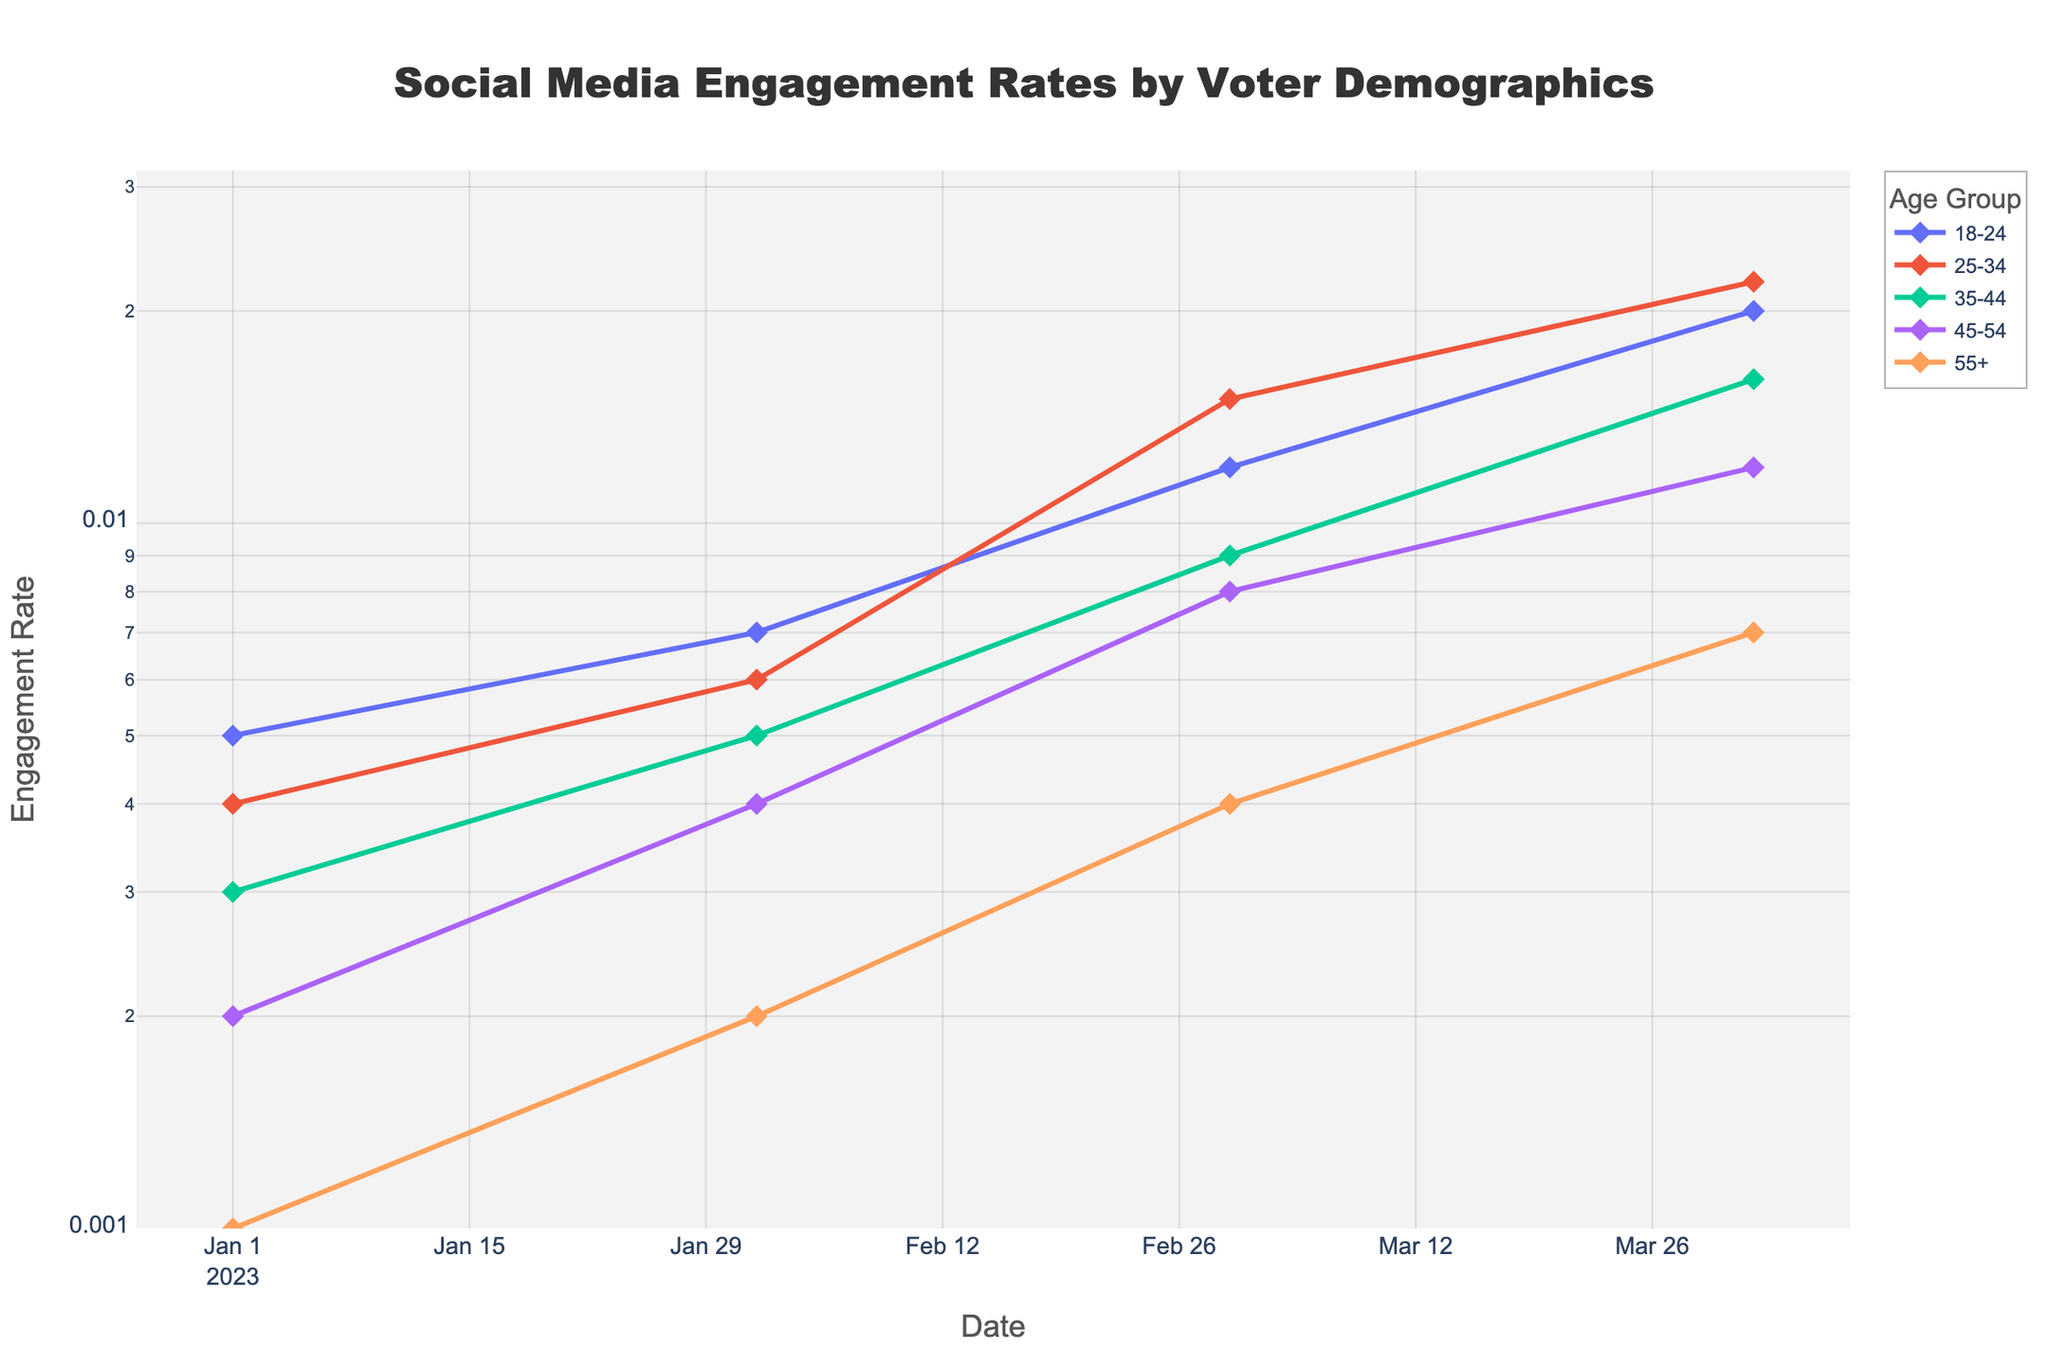What is the title of the plot? The title of the plot is located at the top center and provides a short description of the plot's content.
Answer: Social Media Engagement Rates by Voter Demographics Which voter demographic had the highest engagement rate on 2023-04-01? To find the highest engagement rate on 2023-04-01, examine the end points of the lines for each demographic.
Answer: 25-34 Between which dates did the 18-24 demographic see the fastest growth in engagement rate? To determine this, compare the slopes of the line segments for the 18-24 demographic. The steepest slope indicates the fastest growth.
Answer: 2023-03-01 to 2023-04-01 How many demographic groups are shown in the plot? Count the number of unique lines or legend entries in the plot.
Answer: 5 What is the engagement rate of the 55+ demographic on 2023-02-01? Locate the point on the line for the 55+ demographic at the date 2023-02-01.
Answer: 0.002 How does the engagement rate for the age group 45-54 on 2023-04-01 compare to that on 2023-02-01? Compare the engagement rates for the 45-54 group at the two dates by checking the y-values of those points.
Answer: 3 times higher Which age group showed the smallest change in engagement rates from 2023-01-01 to 2023-04-01? Calculate the difference between the engagement rates on 2023-01-01 and 2023-04-01 for each group, and find the smallest change.
Answer: 55+ What is the trend in engagement rates for the 35-44 age group? Observe the general direction of the 35-44 age group's line over the time period.
Answer: Increasing What date shows the highest overall engagement rate across all demographics? Identify the data point with the highest y-value across all lines.
Answer: 2023-04-01 